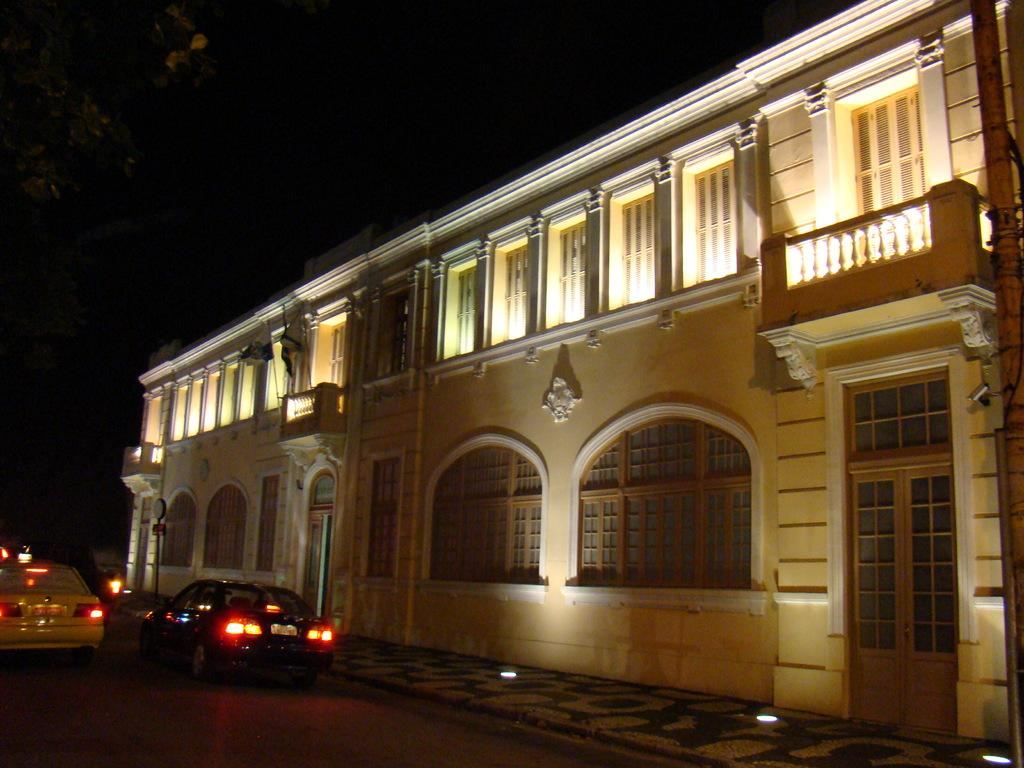What type of structure is present in the image? There is a building in the image. Where is the tree located in the image? The tree is on the left side of the image. What can be seen on the road at the bottom of the image? There are cars on the road at the bottom of the image. What is visible in the background of the image? The sky and lights are visible in the background of the image. Where is the dock located in the image? There is no dock present in the image. What type of map is shown in the image? There is no map present in the image. 